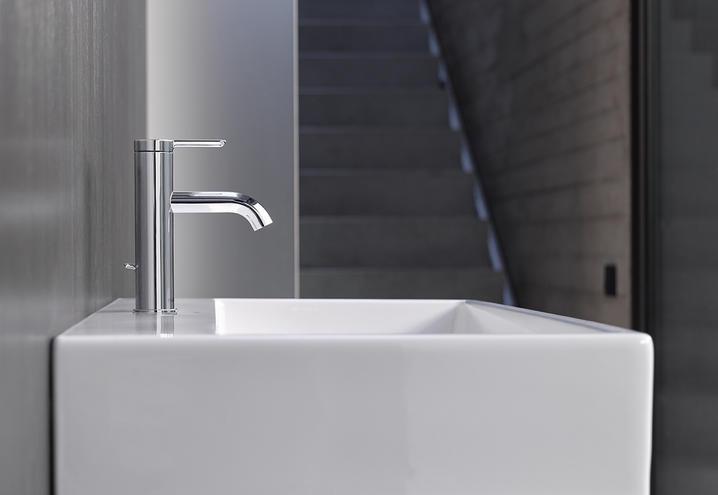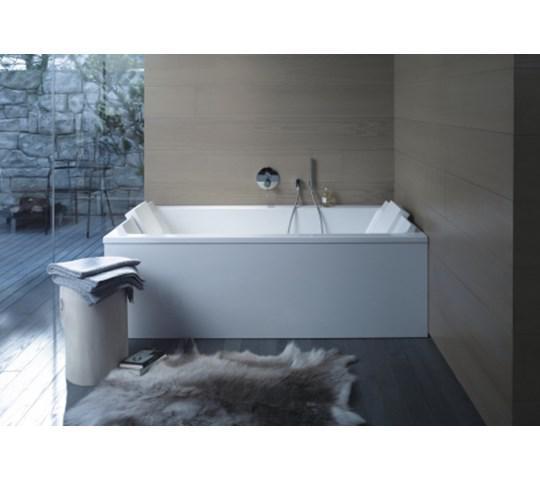The first image is the image on the left, the second image is the image on the right. Given the left and right images, does the statement "In the image to the right, we have a bathtub." hold true? Answer yes or no. Yes. 